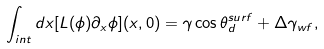Convert formula to latex. <formula><loc_0><loc_0><loc_500><loc_500>\int _ { i n t } d x [ L ( \phi ) \partial _ { x } \phi ] ( x , 0 ) = \gamma \cos \theta _ { d } ^ { s u r f } + \Delta \gamma _ { w f } ,</formula> 